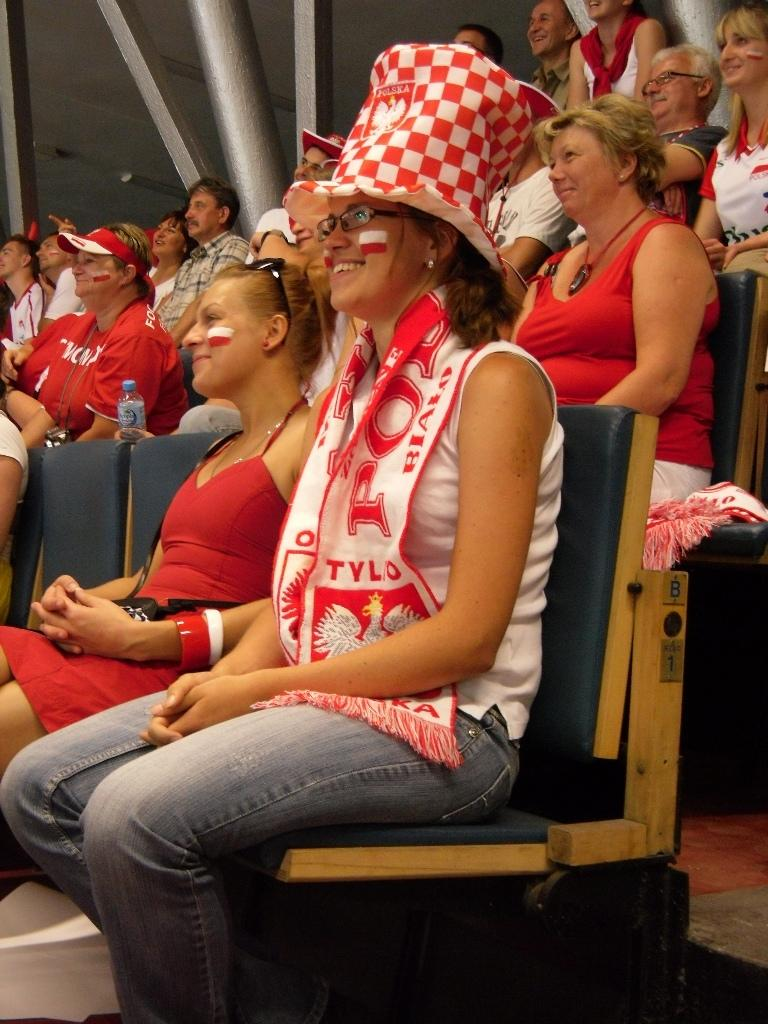What are the people in the image doing? The people in the image are sitting on chairs. Can you describe the gender of the people in the image? There are both men and women in the image. What colors are the dresses of most of the people in the image? Most of the people are wearing white and red color dresses. Who is the manager of the food in the image? There is no mention of food or a manager in the image. 